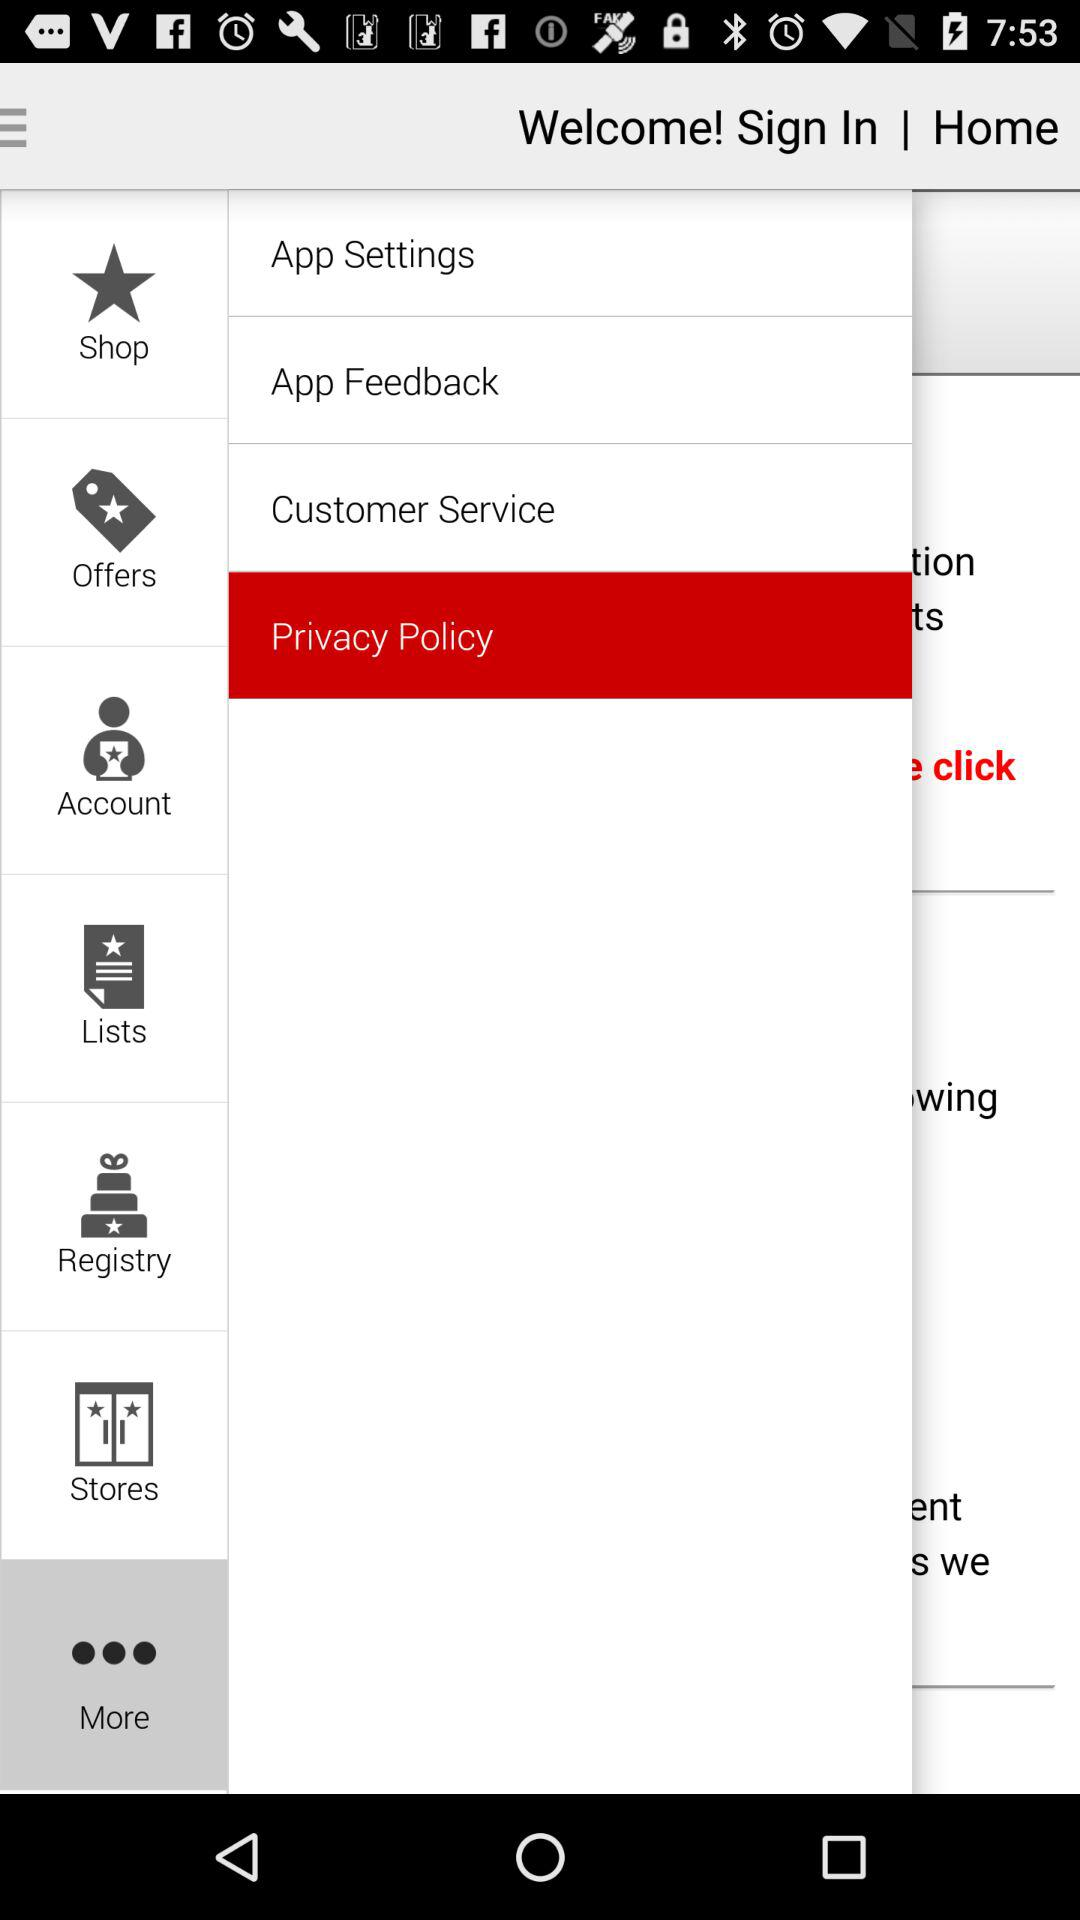Which item is selected? The selected items are "More" and "Privacy Policy". 